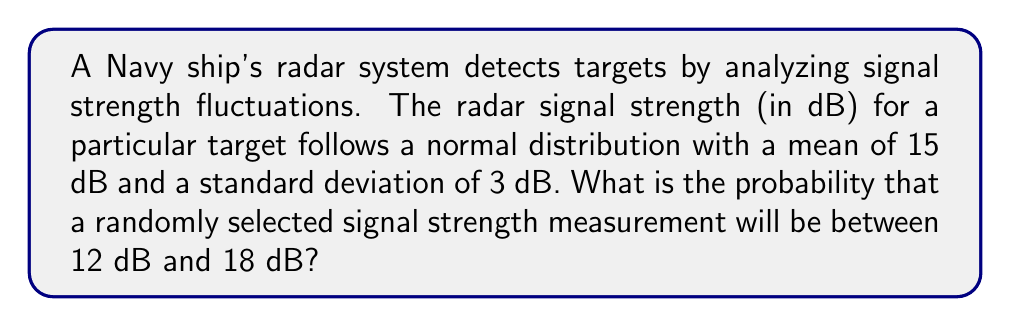Help me with this question. To solve this problem, we'll use the properties of the standard normal distribution:

1) First, we need to standardize the given range using the z-score formula:

   $z = \frac{x - \mu}{\sigma}$

   where $x$ is the value, $\mu$ is the mean, and $\sigma$ is the standard deviation.

2) For the lower bound (12 dB):
   $z_1 = \frac{12 - 15}{3} = -1$

3) For the upper bound (18 dB):
   $z_2 = \frac{18 - 15}{3} = 1$

4) Now, we need to find the area under the standard normal curve between $z_1 = -1$ and $z_2 = 1$.

5) This can be done by using the standard normal distribution table or a calculator with a built-in function.

6) The probability is equal to:
   $P(-1 < Z < 1) = P(Z < 1) - P(Z < -1)$

7) Using a standard normal table or calculator:
   $P(Z < 1) \approx 0.8413$
   $P(Z < -1) \approx 0.1587$

8) Therefore, the probability is:
   $P(-1 < Z < 1) = 0.8413 - 0.1587 = 0.6826$

This means there's approximately a 68.26% chance that a randomly selected signal strength measurement will be between 12 dB and 18 dB.
Answer: 0.6826 or 68.26% 